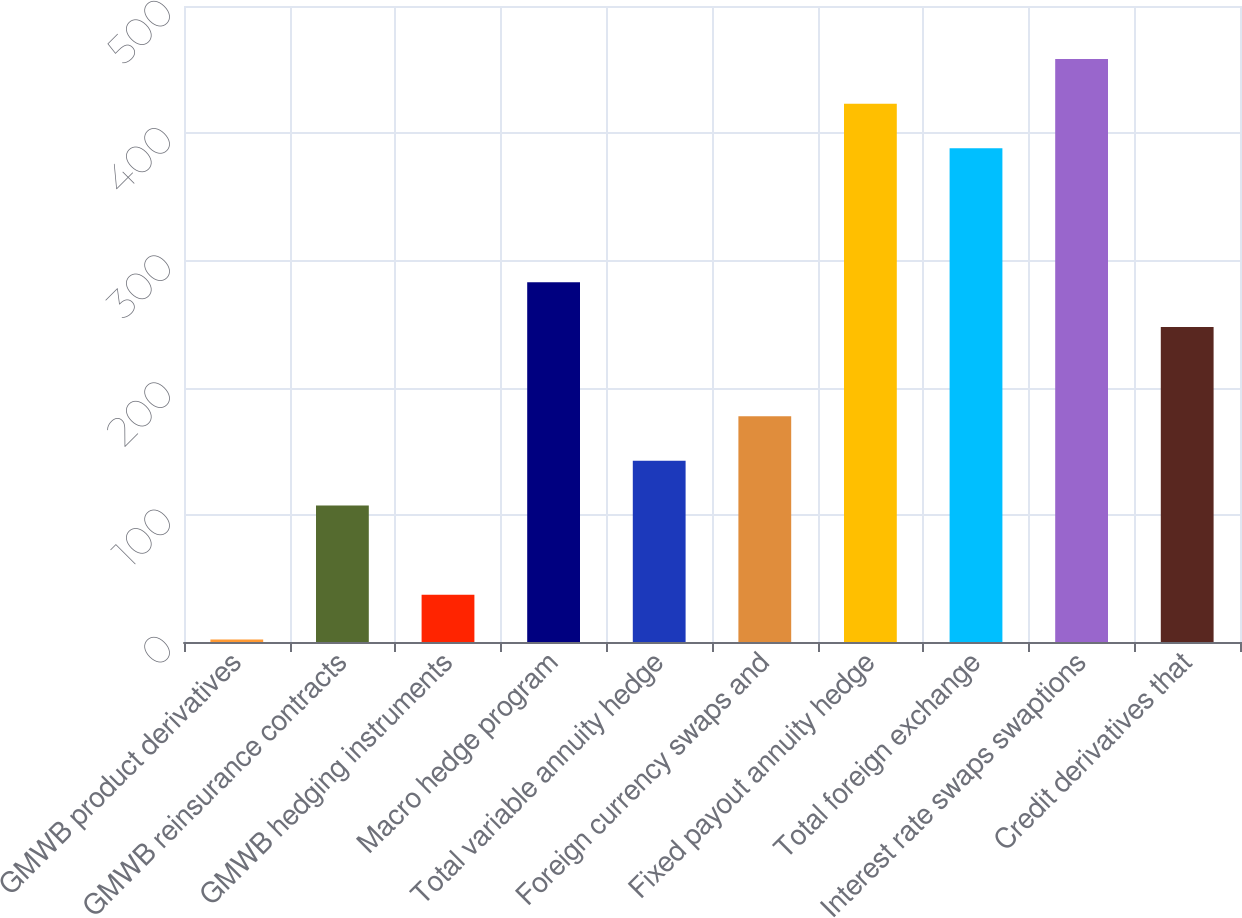<chart> <loc_0><loc_0><loc_500><loc_500><bar_chart><fcel>GMWB product derivatives<fcel>GMWB reinsurance contracts<fcel>GMWB hedging instruments<fcel>Macro hedge program<fcel>Total variable annuity hedge<fcel>Foreign currency swaps and<fcel>Fixed payout annuity hedge<fcel>Total foreign exchange<fcel>Interest rate swaps swaptions<fcel>Credit derivatives that<nl><fcel>2<fcel>107.3<fcel>37.1<fcel>282.8<fcel>142.4<fcel>177.5<fcel>423.2<fcel>388.1<fcel>458.3<fcel>247.7<nl></chart> 